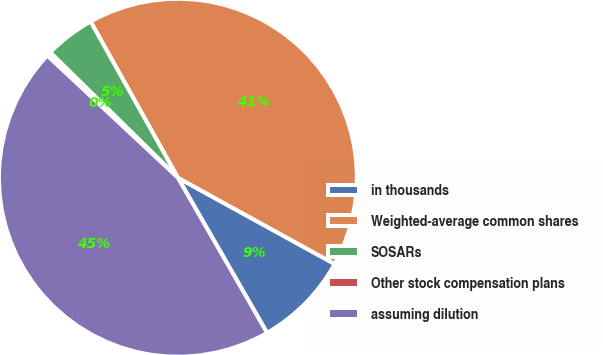<chart> <loc_0><loc_0><loc_500><loc_500><pie_chart><fcel>in thousands<fcel>Weighted-average common shares<fcel>SOSARs<fcel>Other stock compensation plans<fcel>assuming dilution<nl><fcel>8.69%<fcel>41.12%<fcel>4.54%<fcel>0.38%<fcel>45.27%<nl></chart> 